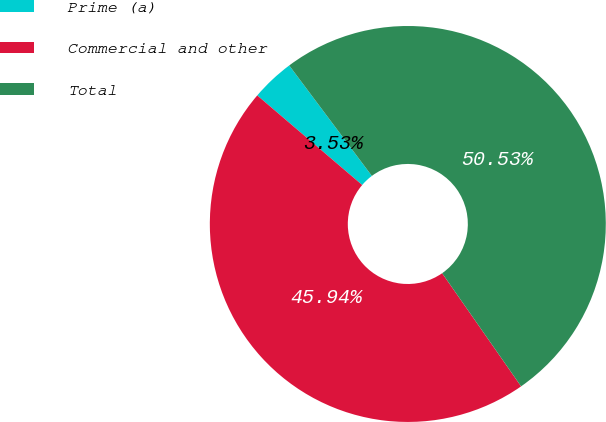<chart> <loc_0><loc_0><loc_500><loc_500><pie_chart><fcel>Prime (a)<fcel>Commercial and other<fcel>Total<nl><fcel>3.53%<fcel>45.94%<fcel>50.53%<nl></chart> 